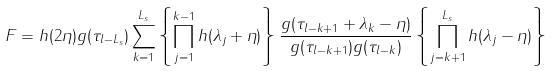Convert formula to latex. <formula><loc_0><loc_0><loc_500><loc_500>F = h ( 2 \eta ) g ( \tau _ { l - L _ { s } } ) \sum ^ { L _ { s } } _ { k = 1 } \left \{ \prod ^ { k - 1 } _ { j = 1 } h ( \lambda _ { j } + \eta ) \right \} \frac { g ( \tau _ { l - k + 1 } + \lambda _ { k } - \eta ) } { g ( \tau _ { l - k + 1 } ) g ( \tau _ { l - k } ) } \left \{ \prod ^ { L _ { s } } _ { j = k + 1 } h ( \lambda _ { j } - \eta ) \right \}</formula> 